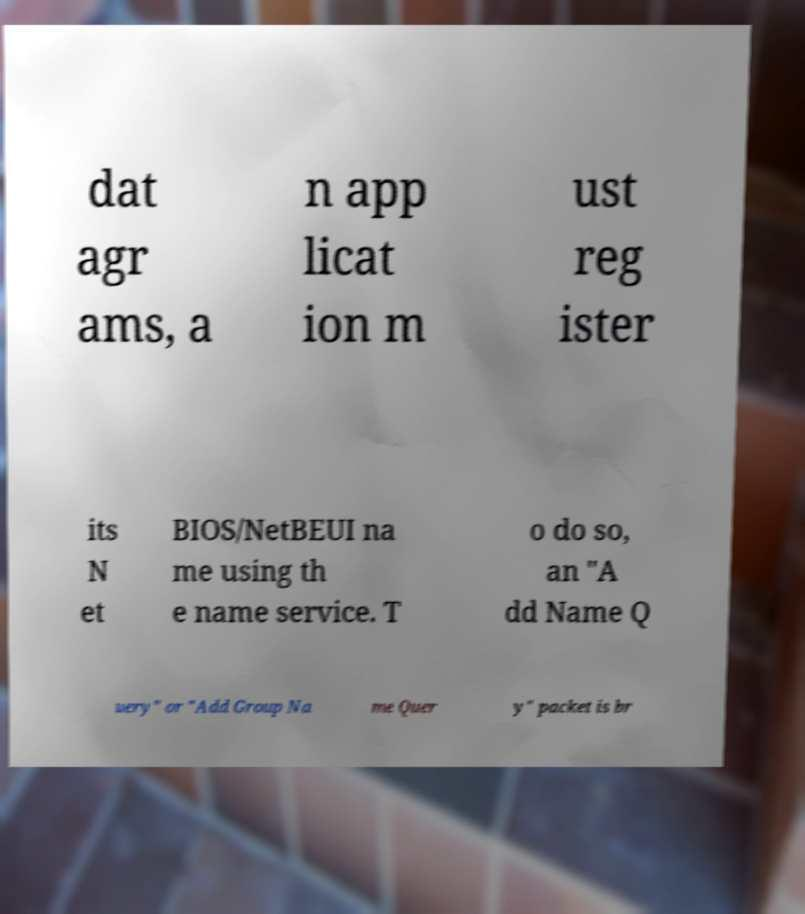What messages or text are displayed in this image? I need them in a readable, typed format. dat agr ams, a n app licat ion m ust reg ister its N et BIOS/NetBEUI na me using th e name service. T o do so, an "A dd Name Q uery" or "Add Group Na me Quer y" packet is br 